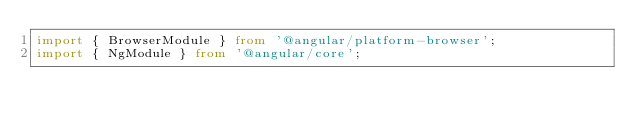<code> <loc_0><loc_0><loc_500><loc_500><_TypeScript_>import { BrowserModule } from '@angular/platform-browser';
import { NgModule } from '@angular/core';
</code> 